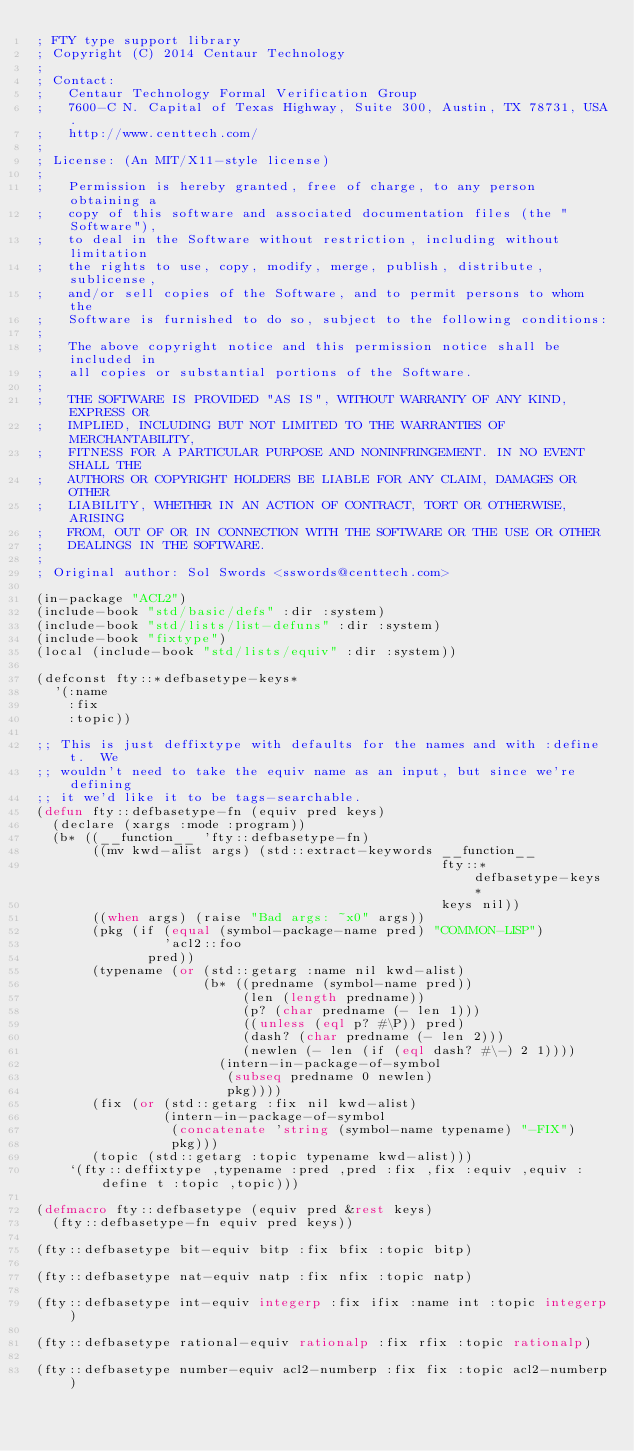<code> <loc_0><loc_0><loc_500><loc_500><_Lisp_>; FTY type support library
; Copyright (C) 2014 Centaur Technology
;
; Contact:
;   Centaur Technology Formal Verification Group
;   7600-C N. Capital of Texas Highway, Suite 300, Austin, TX 78731, USA.
;   http://www.centtech.com/
;
; License: (An MIT/X11-style license)
;
;   Permission is hereby granted, free of charge, to any person obtaining a
;   copy of this software and associated documentation files (the "Software"),
;   to deal in the Software without restriction, including without limitation
;   the rights to use, copy, modify, merge, publish, distribute, sublicense,
;   and/or sell copies of the Software, and to permit persons to whom the
;   Software is furnished to do so, subject to the following conditions:
;
;   The above copyright notice and this permission notice shall be included in
;   all copies or substantial portions of the Software.
;
;   THE SOFTWARE IS PROVIDED "AS IS", WITHOUT WARRANTY OF ANY KIND, EXPRESS OR
;   IMPLIED, INCLUDING BUT NOT LIMITED TO THE WARRANTIES OF MERCHANTABILITY,
;   FITNESS FOR A PARTICULAR PURPOSE AND NONINFRINGEMENT. IN NO EVENT SHALL THE
;   AUTHORS OR COPYRIGHT HOLDERS BE LIABLE FOR ANY CLAIM, DAMAGES OR OTHER
;   LIABILITY, WHETHER IN AN ACTION OF CONTRACT, TORT OR OTHERWISE, ARISING
;   FROM, OUT OF OR IN CONNECTION WITH THE SOFTWARE OR THE USE OR OTHER
;   DEALINGS IN THE SOFTWARE.
;
; Original author: Sol Swords <sswords@centtech.com>

(in-package "ACL2")
(include-book "std/basic/defs" :dir :system)
(include-book "std/lists/list-defuns" :dir :system)
(include-book "fixtype")
(local (include-book "std/lists/equiv" :dir :system))

(defconst fty::*defbasetype-keys*
  '(:name
    :fix
    :topic))

;; This is just deffixtype with defaults for the names and with :define t.  We
;; wouldn't need to take the equiv name as an input, but since we're defining
;; it we'd like it to be tags-searchable.
(defun fty::defbasetype-fn (equiv pred keys)
  (declare (xargs :mode :program))
  (b* ((__function__ 'fty::defbasetype-fn)
       ((mv kwd-alist args) (std::extract-keywords __function__
                                                   fty::*defbasetype-keys*
                                                   keys nil))
       ((when args) (raise "Bad args: ~x0" args))
       (pkg (if (equal (symbol-package-name pred) "COMMON-LISP")
                'acl2::foo
              pred))
       (typename (or (std::getarg :name nil kwd-alist)
                     (b* ((predname (symbol-name pred))
                          (len (length predname))
                          (p? (char predname (- len 1)))
                          ((unless (eql p? #\P)) pred)
                          (dash? (char predname (- len 2)))
                          (newlen (- len (if (eql dash? #\-) 2 1))))
                       (intern-in-package-of-symbol
                        (subseq predname 0 newlen)
                        pkg))))
       (fix (or (std::getarg :fix nil kwd-alist)
                (intern-in-package-of-symbol
                 (concatenate 'string (symbol-name typename) "-FIX")
                 pkg)))
       (topic (std::getarg :topic typename kwd-alist)))
    `(fty::deffixtype ,typename :pred ,pred :fix ,fix :equiv ,equiv :define t :topic ,topic)))

(defmacro fty::defbasetype (equiv pred &rest keys)
  (fty::defbasetype-fn equiv pred keys))

(fty::defbasetype bit-equiv bitp :fix bfix :topic bitp)

(fty::defbasetype nat-equiv natp :fix nfix :topic natp)

(fty::defbasetype int-equiv integerp :fix ifix :name int :topic integerp)

(fty::defbasetype rational-equiv rationalp :fix rfix :topic rationalp)

(fty::defbasetype number-equiv acl2-numberp :fix fix :topic acl2-numberp)
</code> 